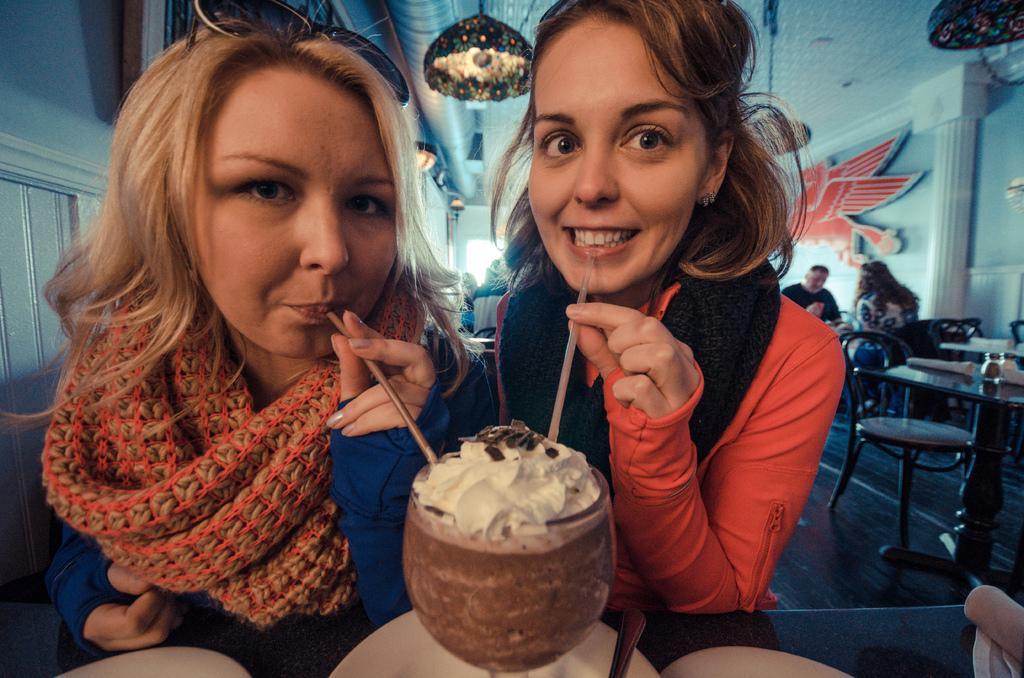Can you describe this image briefly? In the image we can see two women wearing clothes and they are holding straws, behind them there are other people sitting, they are wearing clothes. We can even see there are many chairs and tables and on the tables we can see few objects. Here we can see the wall, decorating, a floor and lights. 